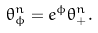<formula> <loc_0><loc_0><loc_500><loc_500>\theta _ { \phi } ^ { n } = e ^ { \phi } \theta _ { + } ^ { n } .</formula> 